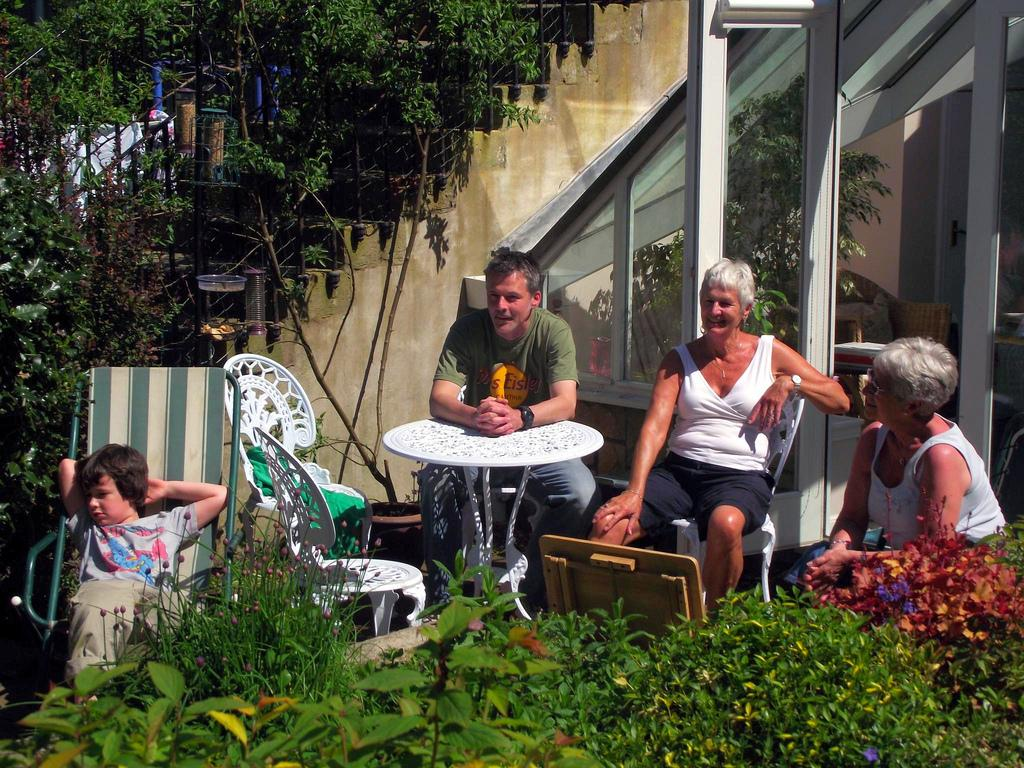How many people are present in the image? There are four people in the image. What are the people doing in the image? The people are seated on chairs. What other objects can be seen in the image besides the people? There are plants and a table in the image. What type of structure is visible in the background? There is a house in the image. What color is the bead that is being used to force the jelly to move in the image? There is no bead or jelly present in the image. 